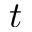<formula> <loc_0><loc_0><loc_500><loc_500>t</formula> 